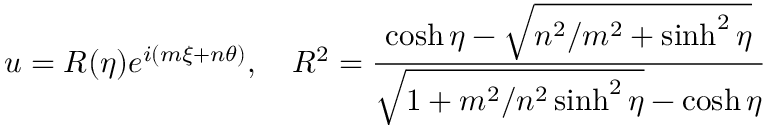<formula> <loc_0><loc_0><loc_500><loc_500>u = R ( \eta ) e ^ { i ( m \xi + n \theta ) } , \quad R ^ { 2 } = { \frac { \cosh \eta - \sqrt { n ^ { 2 } / m ^ { 2 } + \sinh ^ { 2 } \eta } } { \sqrt { 1 + m ^ { 2 } / n ^ { 2 } \sinh ^ { 2 } \eta } - \cosh \eta } }</formula> 